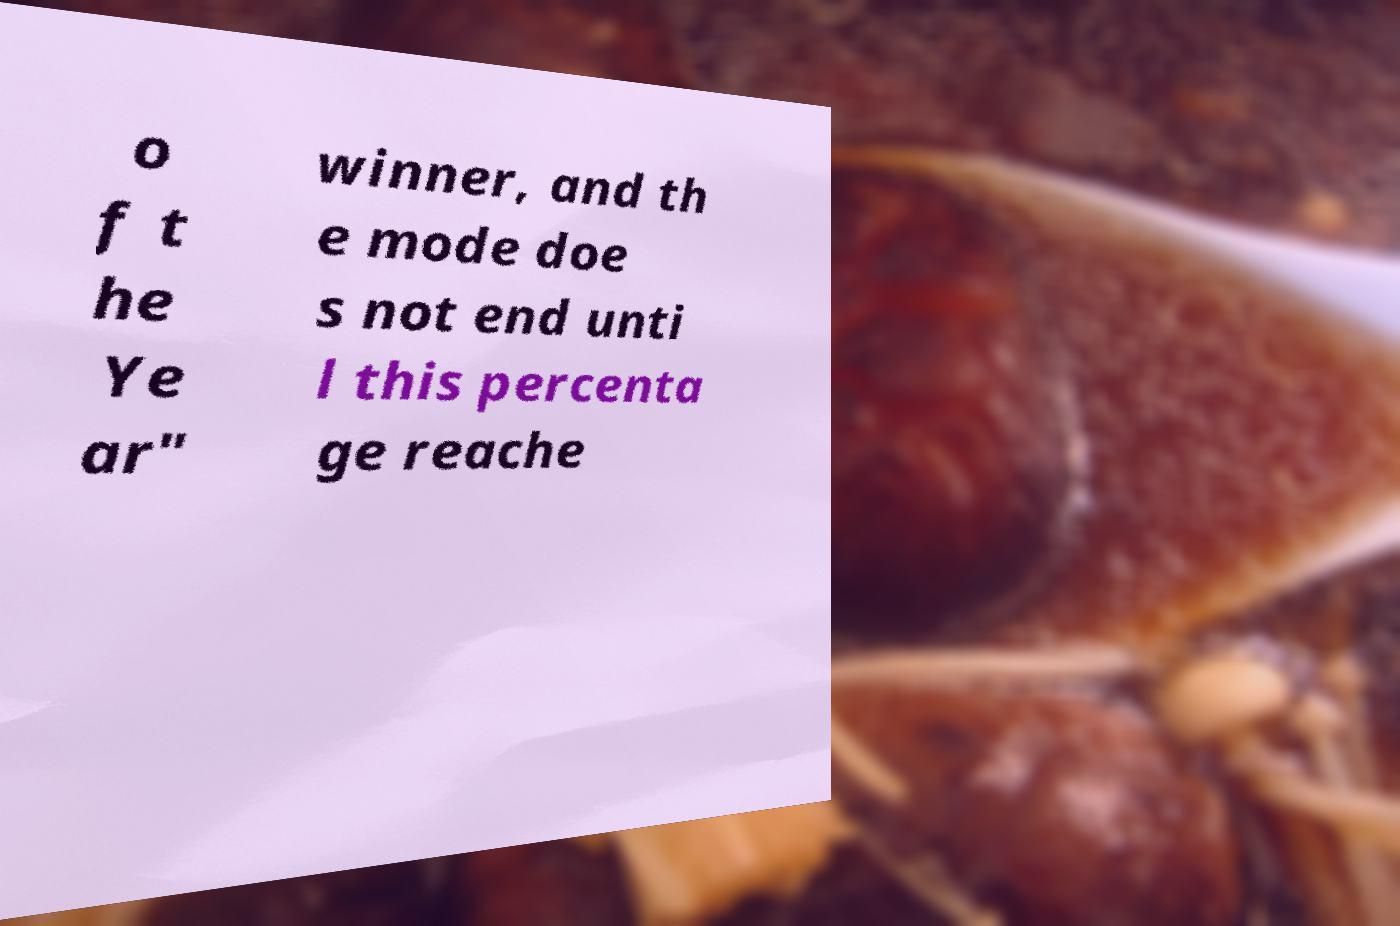Can you accurately transcribe the text from the provided image for me? o f t he Ye ar" winner, and th e mode doe s not end unti l this percenta ge reache 